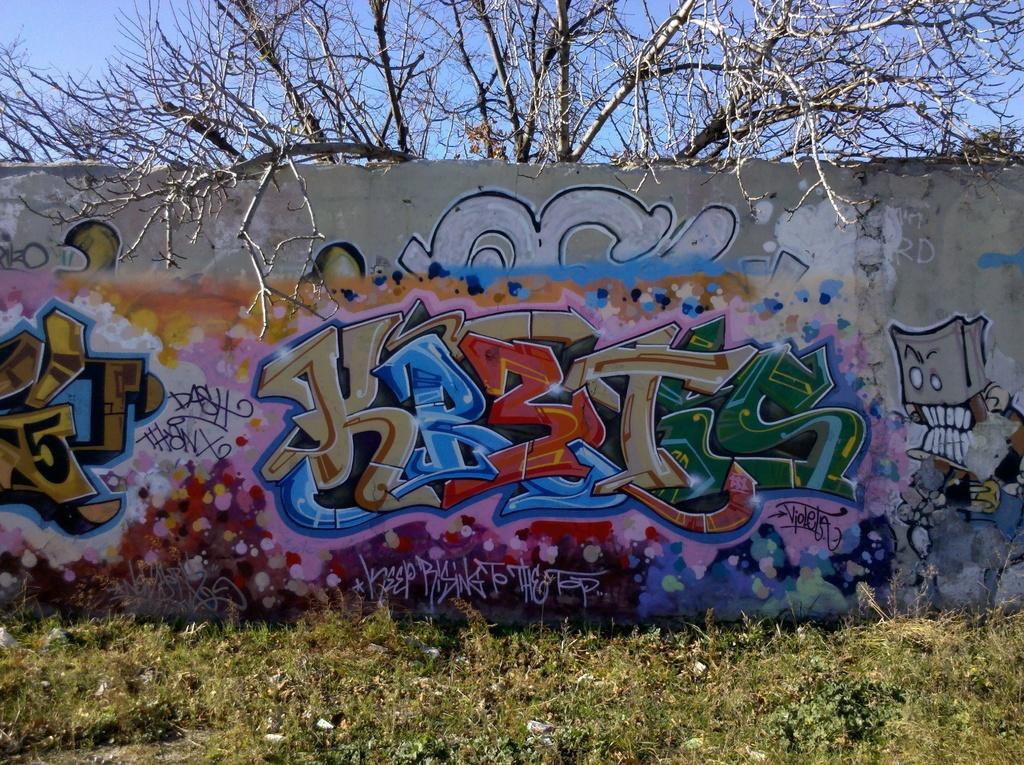In one or two sentences, can you explain what this image depicts? In the center of the image there is a wall and graffiti on it. In the background there is a sky and tree. 